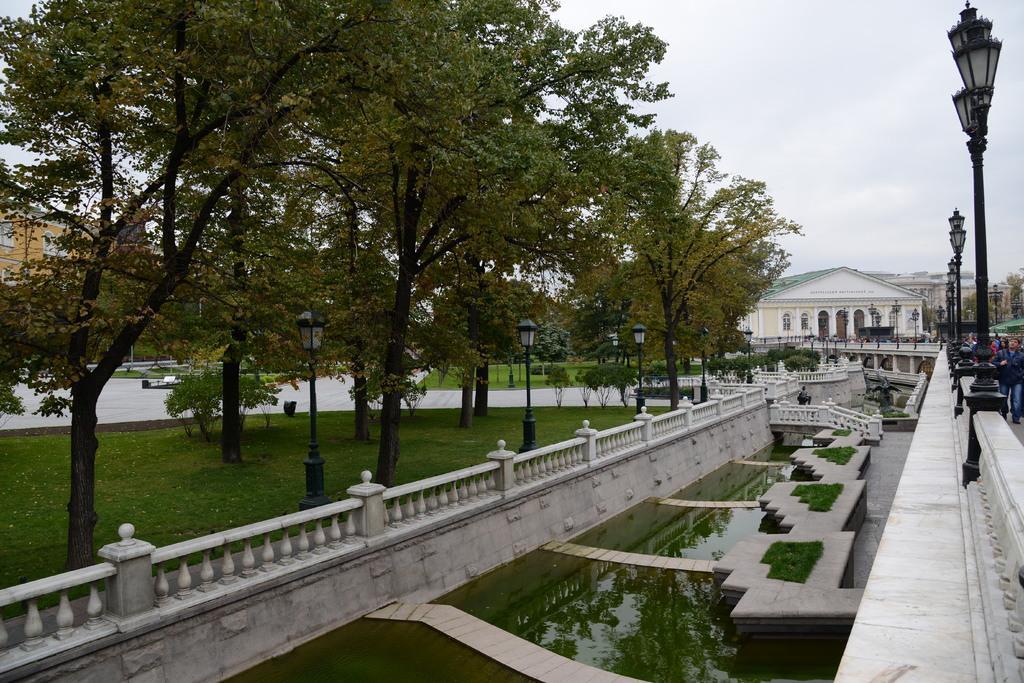Can you describe this image briefly? In the picture I can see water and there is a fence wall on either sides of it and there are few persons and street lights in the right corner and there are few trees and a greenery ground in the left corner and there are few buildings in the background. 